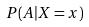Convert formula to latex. <formula><loc_0><loc_0><loc_500><loc_500>P ( A | X = x )</formula> 